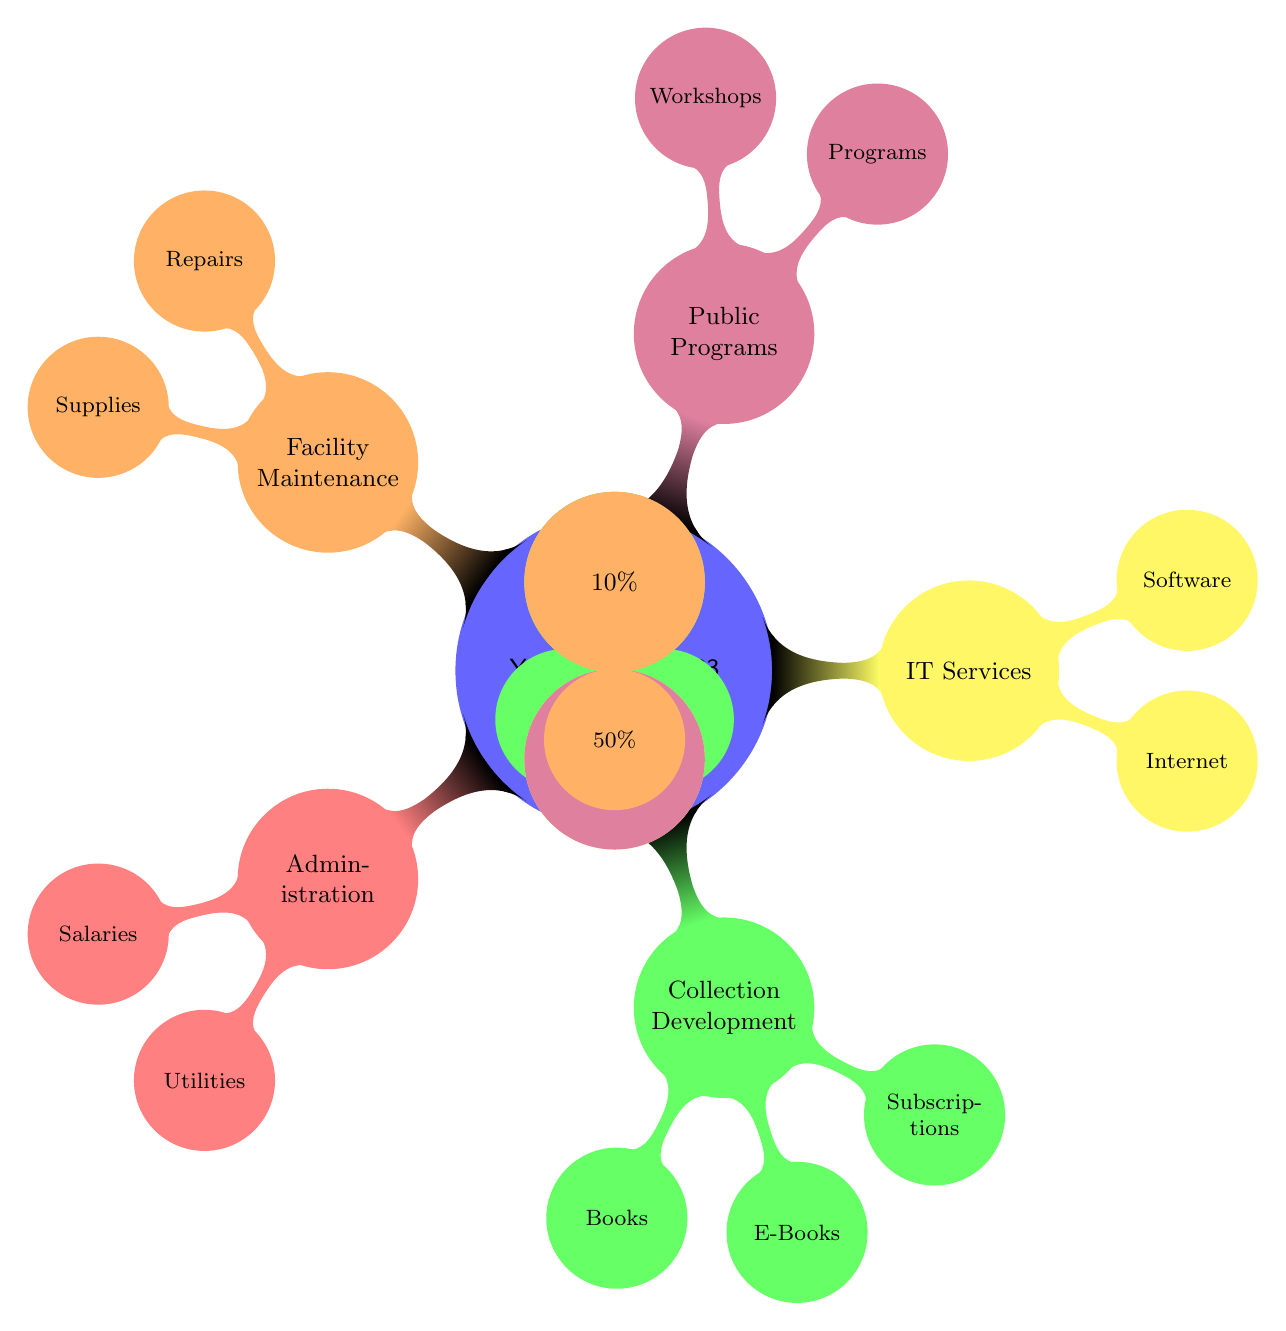What is the total percentage allocated to Administration? The Administration section has one edge that connects it to the Yearly Budget node showing 20%. In addition, within Administration, Salaries account for 70% and Utilities for 30%, which sum up to 100%, but only 20% of the total budget goes to Administration. Thus, the answer remains at 20%.
Answer: 20% Which department has the highest percentage allocation? To find the department with the highest allocation, we look at the percentages connected to each department node. Administration is at 20%, Collection Development is at 30%, IT Services is at 15%, Public Programs is at 25%, and Facility Maintenance is at 10%. The highest percentage among these is Collection Development at 30%.
Answer: 30% What is the percentage allocation for Books in Collection Development? In the Collection Development department, the Books node is connected to it, showing an allocation of 50% for Books specifically. The total allocation for Collection Development is 30%, but within it, Books takes up half of this individual section.
Answer: 50% How much of the budget is allocated to IT Services? The IT Services department node has an edge leading to it that shows an overall allocation of 15% of the total budget. This is the percentage associated directly with the IT Services node.
Answer: 15% What is the combined percentage for Public Programs Workshops and IT Services Software? To find the combined value, we first look at the percentages for Workshops in Public Programs, which is 40% of the total allocation for Public Programs (25%), and for Software in IT Services, which is 50% of the total allocation for IT Services (15%). Workshops thus contribute 10% and Software contributes 7.5%. Summing these gives us a total of 17.5%.
Answer: 17.5% Which two categories share the same allocation percentage for their internal segments? Looking closely at the diagram, we note that both Administration and Facility Maintenance have two segments each that are allocated 50% to their respective internal components (Salaries and Utilities for Administration; Repairs and Supplies for Facility Maintenance), leading to one possible conclusion. Therefore, they share this characteristic.
Answer: Administration and Facility Maintenance What fraction of the total budget is allocated to E-Books? Within the Collection Development department, E-Books is allotted 30% of the departmental allocation. Since the total for Collection Development is 30% of the total budget, E-Books, therefore, accounts for 30% of 30%, which results in 9% of the overall budget.
Answer: 9% How is the IT Services budget divided? The IT Services department is divided into two parts, Internet and Software, with each allocated 50%. Since their combined percentage is 15% of the total budget, each segment receives half of that, which is also distinctly 7.5% each.
Answer: Internet 7.5%, Software 7.5% What is the total number of departments represented in the diagram? The diagram includes five distinct departments: Administration, Collection Development, IT Services, Public Programs, and Facility Maintenance. Therefore, the total count of departments visually represented is simply five.
Answer: 5 